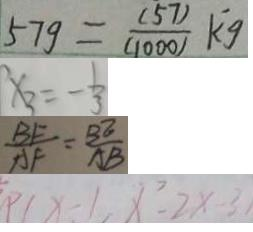<formula> <loc_0><loc_0><loc_500><loc_500>5 7 g = \frac { ( 5 7 ) } { ( 1 0 0 0 ) } k g 
 x _ { 3 } = - \frac { 1 } { 3 } 
 \frac { B F } { A F } = \frac { B E } { A B } 
 P ( x - 1 , x ^ { 2 } - 2 x - 3</formula> 